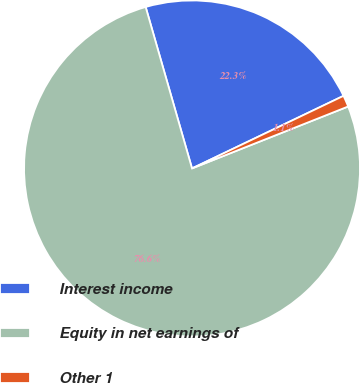<chart> <loc_0><loc_0><loc_500><loc_500><pie_chart><fcel>Interest income<fcel>Equity in net earnings of<fcel>Other 1<nl><fcel>22.34%<fcel>76.56%<fcel>1.1%<nl></chart> 